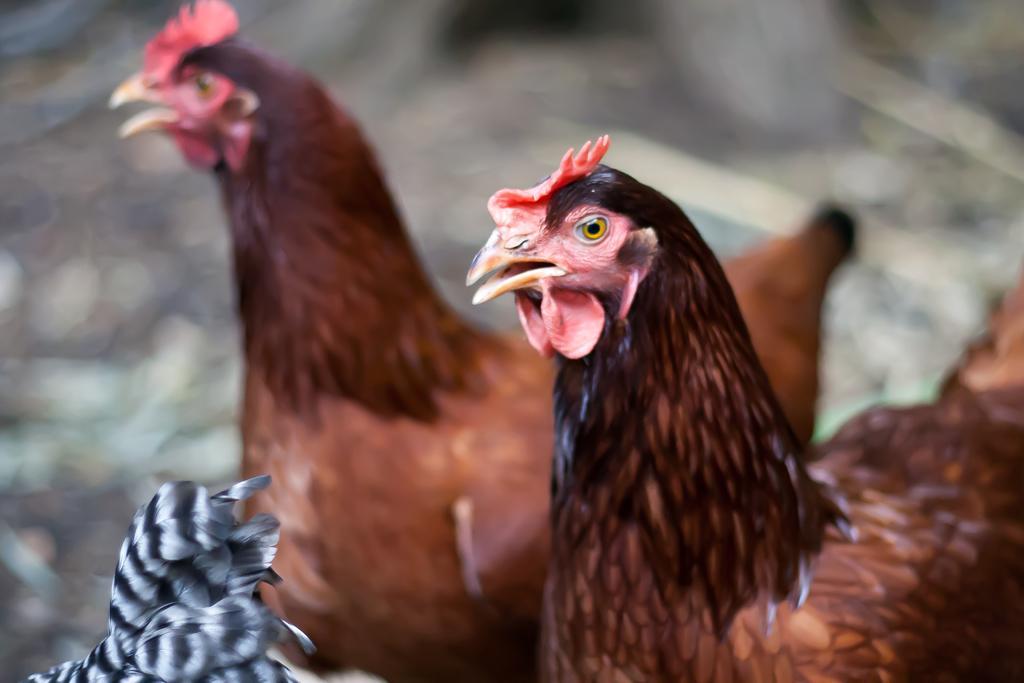How would you summarize this image in a sentence or two? In this image in the foreground there are two hens and there is a blurry background, at the bottom there are feathers. 